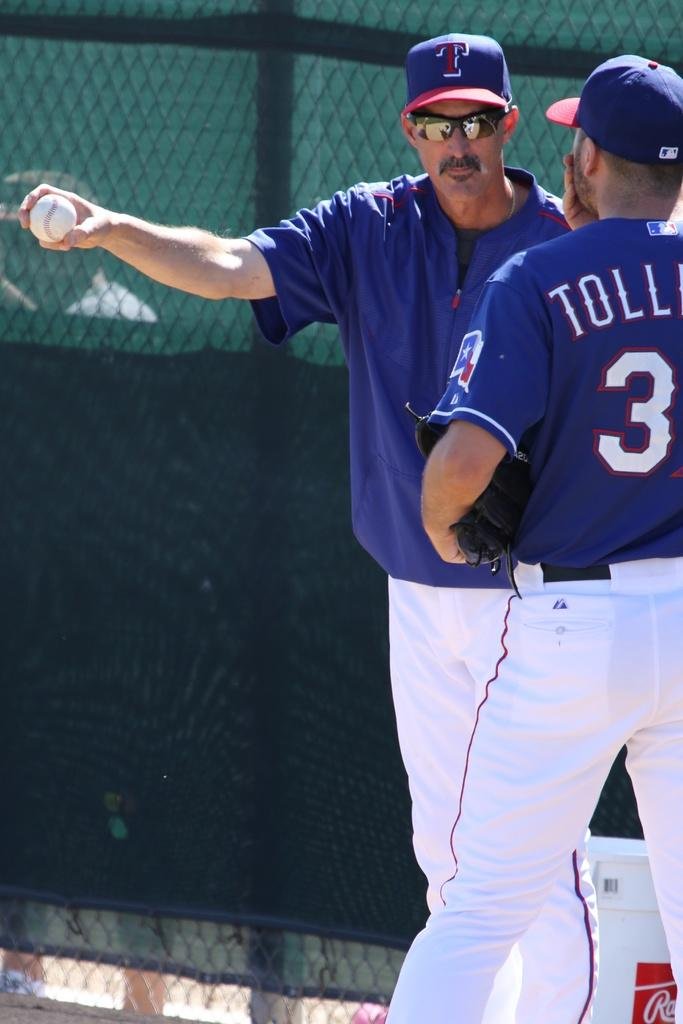<image>
Create a compact narrative representing the image presented. Two men in Texas baseball uniforms are standing next to each other. 